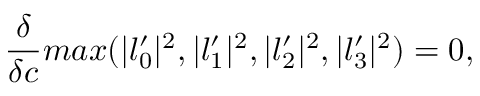<formula> <loc_0><loc_0><loc_500><loc_500>{ \frac { \delta } { \delta c } } \max ( | l _ { 0 } ^ { \prime } | ^ { 2 } , | l _ { 1 } ^ { \prime } | ^ { 2 } , | l _ { 2 } ^ { \prime } | ^ { 2 } , | l _ { 3 } ^ { \prime } | ^ { 2 } ) = 0 ,</formula> 